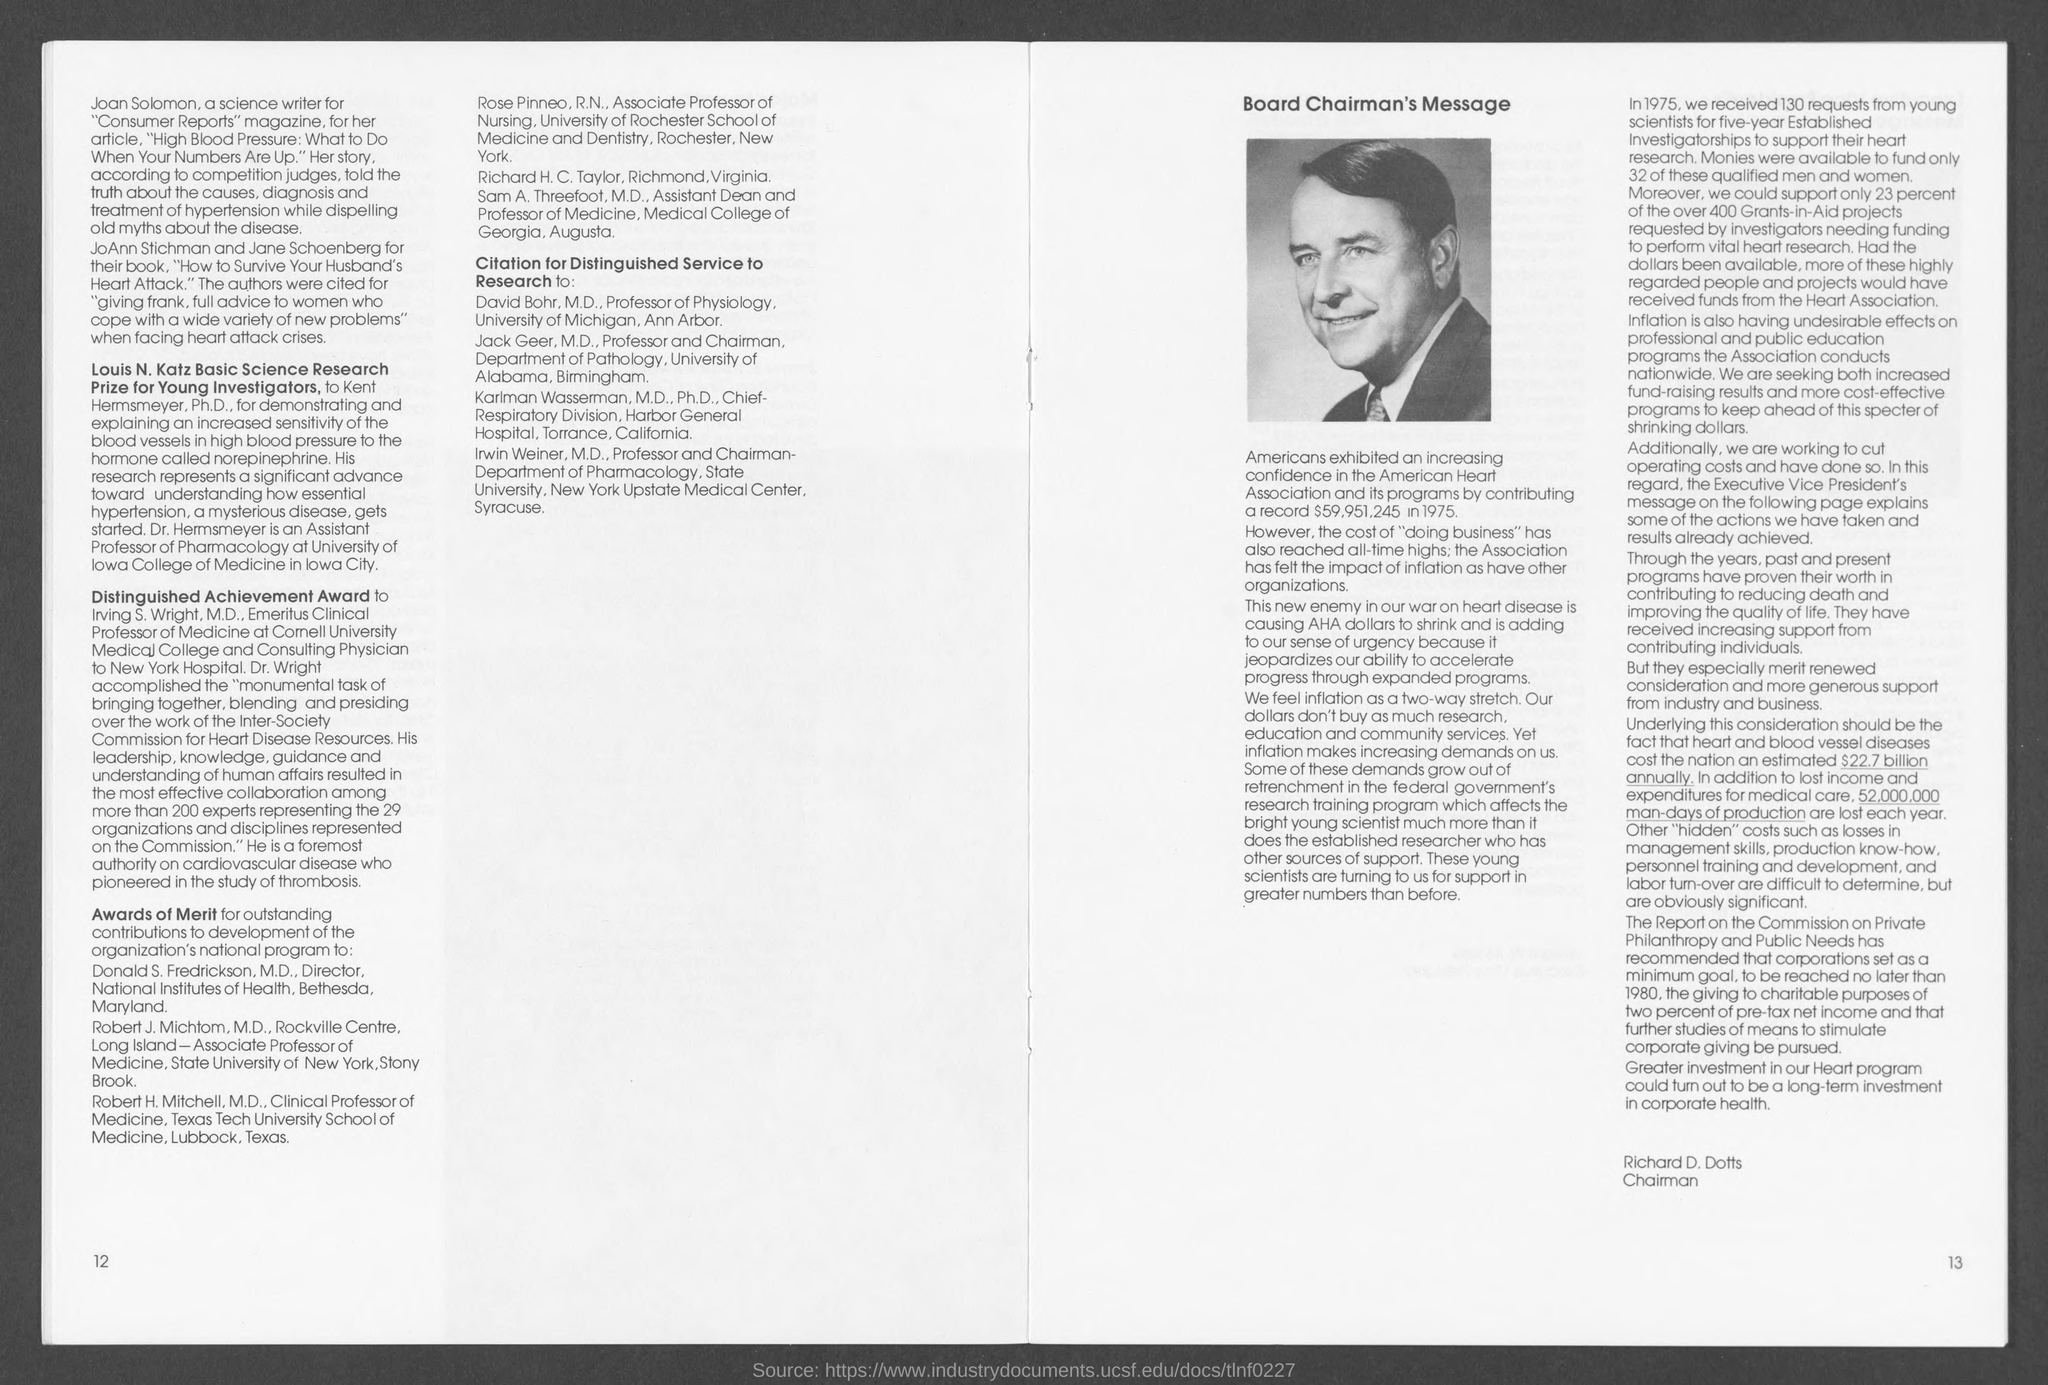Mention a couple of crucial points in this snapshot. The number at the bottom right page is 13. Richard D. Dotts holds the position of Chairman. The number at the bottom left page is 12. 